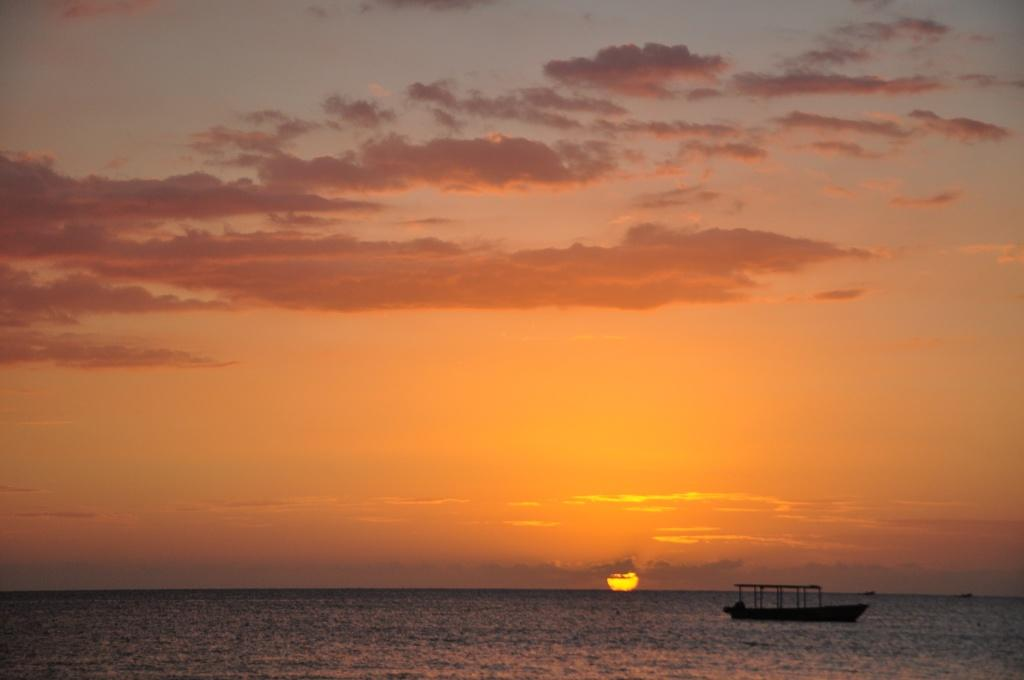What is the main subject of the picture? The main subject of the picture is water. What is on the water in the image? There is a boat on the water in the image. What can be observed in the sky in the image? There is a sunset present in the image. Where is the gun hidden in the image? There is no gun present in the image. What type of minister is depicted in the image? There is no minister present in the image. 